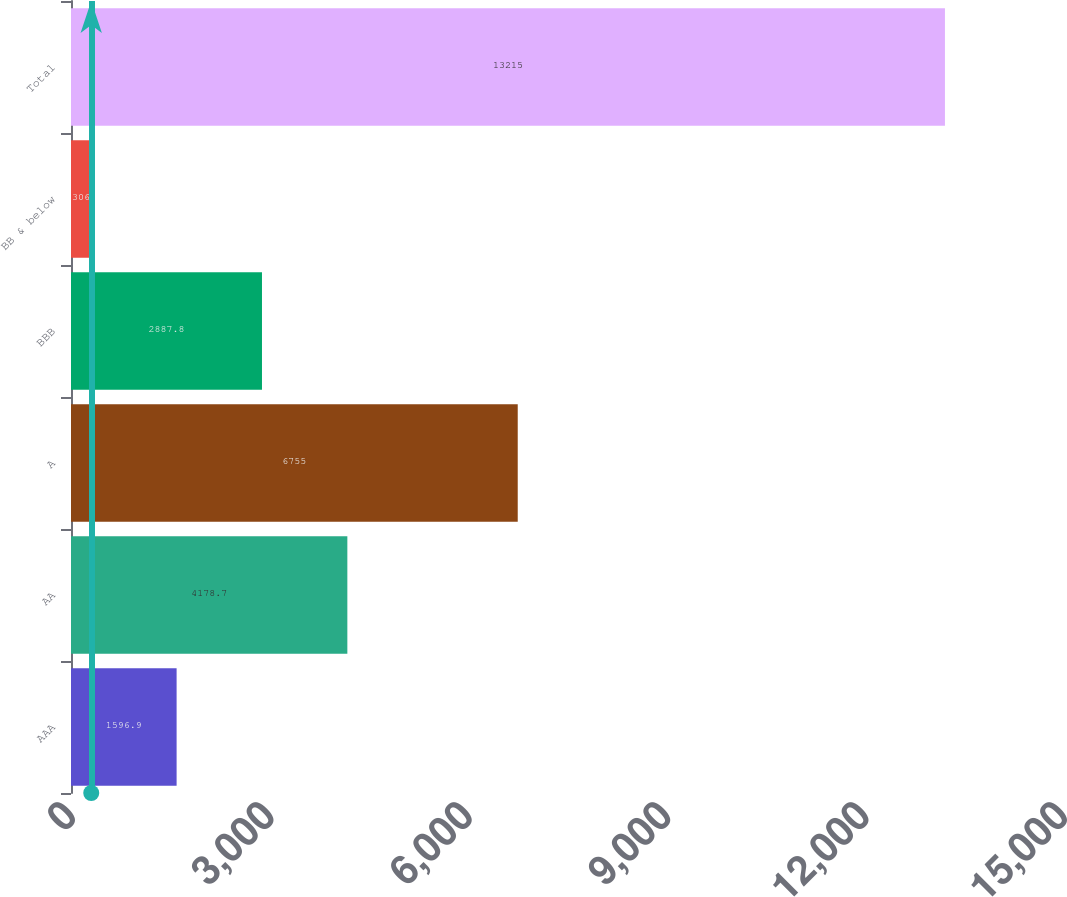Convert chart. <chart><loc_0><loc_0><loc_500><loc_500><bar_chart><fcel>AAA<fcel>AA<fcel>A<fcel>BBB<fcel>BB & below<fcel>Total<nl><fcel>1596.9<fcel>4178.7<fcel>6755<fcel>2887.8<fcel>306<fcel>13215<nl></chart> 